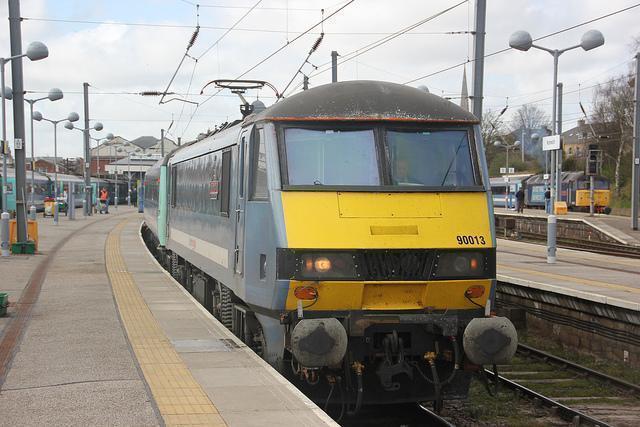For what group of people is the yellow area on the platform built?
Indicate the correct response and explain using: 'Answer: answer
Rationale: rationale.'
Options: Handicapped people, elderly people, blind people, pregnant women. Answer: blind people.
Rationale: The yellow stripe on the train platform is textured so blind people can detect them with their canes. 